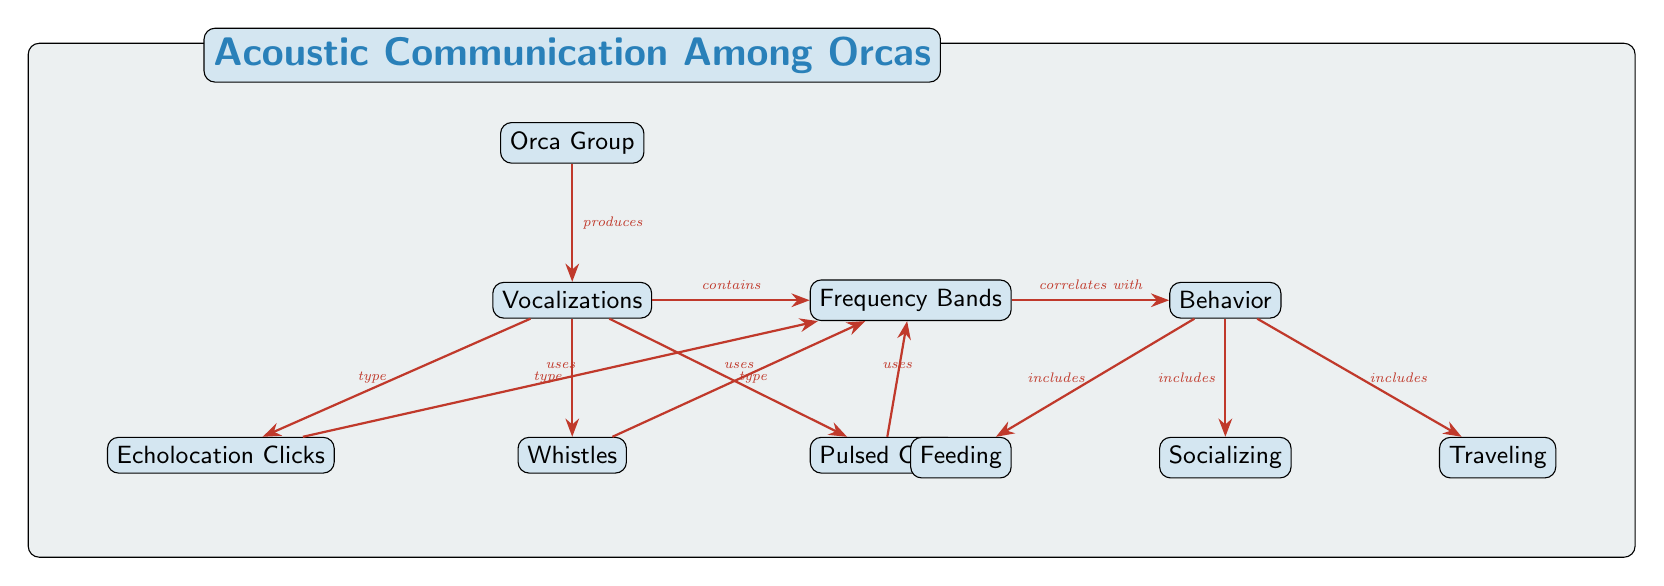What are the three types of vocalizations among orcas? The diagram shows three types of vocalizations produced by orcas: echolocation clicks, whistles, and pulsed calls.
Answer: echolocation clicks, whistles, pulsed calls What behavior correlates with frequency bands? According to the diagram, frequency bands correlate with behavior, showing a connection between the two elements.
Answer: behavior How many nodes represent vocalization types? The diagram displays three nodes under the vocalizations category, indicating the different types present (echolocation clicks, whistles, pulsed calls).
Answer: 3 What includes the behavior node? The behavior node includes feeding, socializing, and traveling, as indicated by the edges leading from the behavior node to these three behaviors.
Answer: feeding, socializing, traveling Which vocalization type uses frequency bands? Three vocalization types (echolocation clicks, whistles, pulsed calls) utilize frequency bands, as seen from the edges connecting them to the frequency bands node.
Answer: echolocation clicks, whistles, pulsed calls What does the orca group produce? The orca group produces vocalizations, as indicated by the direct connection from the orca group node to the vocalizations node.
Answer: vocalizations Which behavior is associated with socializing? The behavior of socializing has a direct correlation shown in the diagram and is one of the behaviors listed under the behavior node.
Answer: socializing How many edges connect vocalizations to behavior? The diagram illustrates one edge connecting vocalizations to the behavior node, indicating a correlation between these two elements.
Answer: 1 What type of diagram is this? The diagram is a Natural Science Diagram focused on the acoustic communication among orcas, representing their vocalizations and corresponding behaviors.
Answer: Natural Science Diagram 